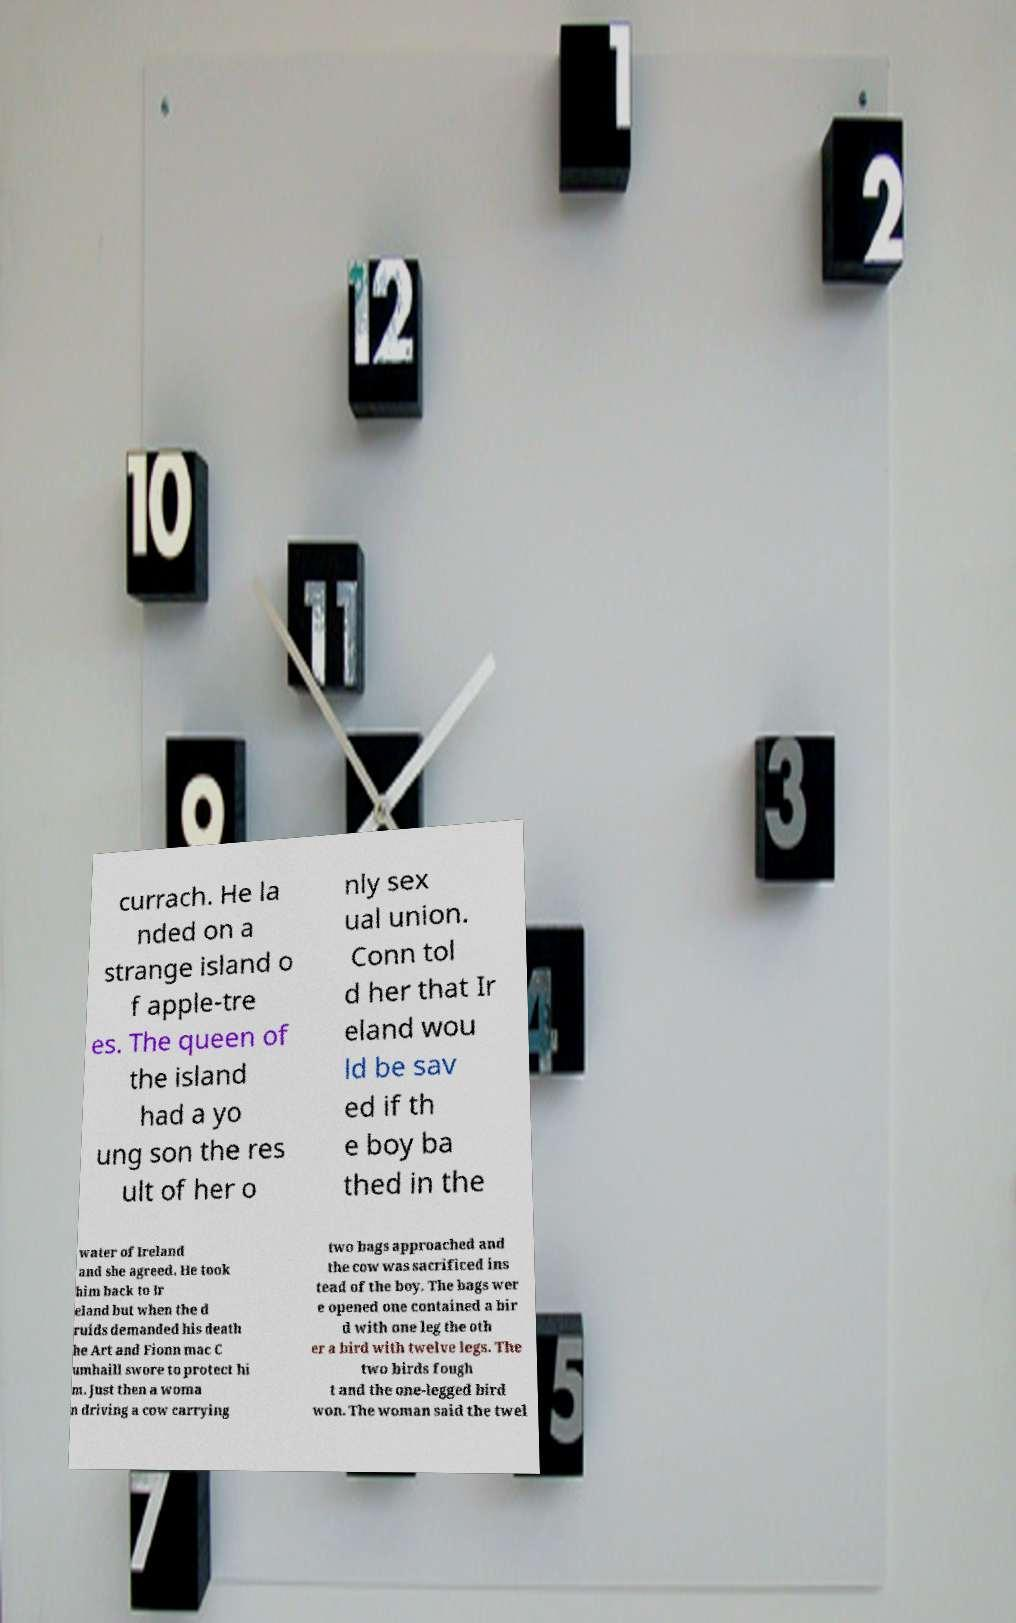Please identify and transcribe the text found in this image. currach. He la nded on a strange island o f apple-tre es. The queen of the island had a yo ung son the res ult of her o nly sex ual union. Conn tol d her that Ir eland wou ld be sav ed if th e boy ba thed in the water of Ireland and she agreed. He took him back to Ir eland but when the d ruids demanded his death he Art and Fionn mac C umhaill swore to protect hi m. Just then a woma n driving a cow carrying two bags approached and the cow was sacrificed ins tead of the boy. The bags wer e opened one contained a bir d with one leg the oth er a bird with twelve legs. The two birds fough t and the one-legged bird won. The woman said the twel 